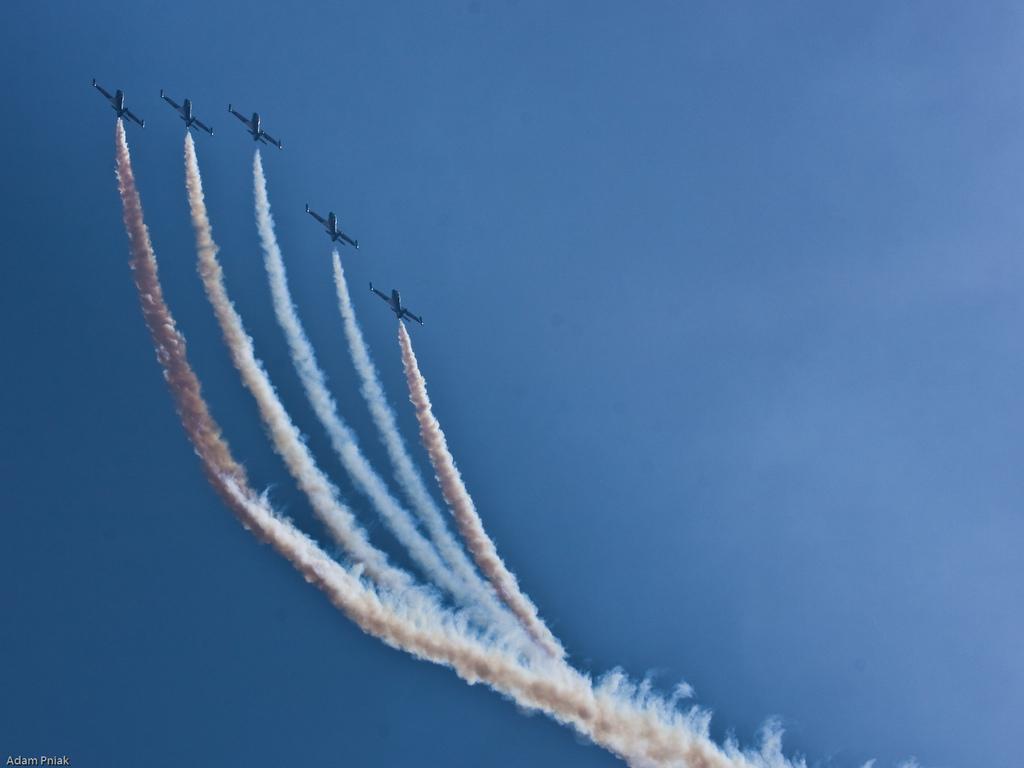Could you give a brief overview of what you see in this image? In this picture I can see few jet planes release smoke in the sky. 